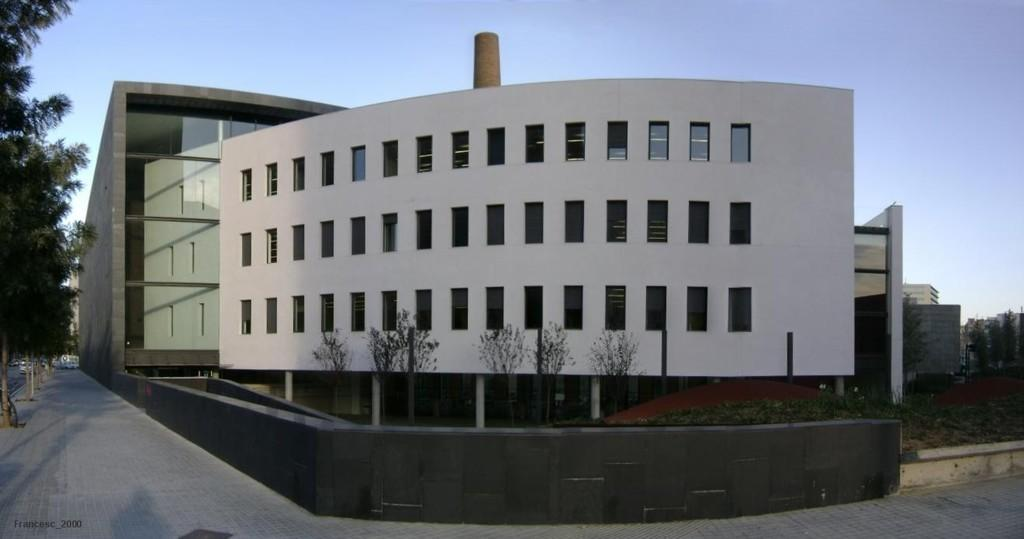What type of structures can be seen in the image? There are buildings in the image. What type of vegetation is present in the image? There are plants, trees, and grass in the image. What mode of transportation can be seen in the image? There is a vehicle and a bicycle in the image. What part of the natural environment is visible in the image? The sky is visible in the image. What type of sock is hanging from the tree in the image? There is no sock present in the image; it features buildings, plants, trees, grass, a vehicle, a bicycle, and the sky. What type of metal is used to construct the cannon in the image? There is no cannon present in the image. 